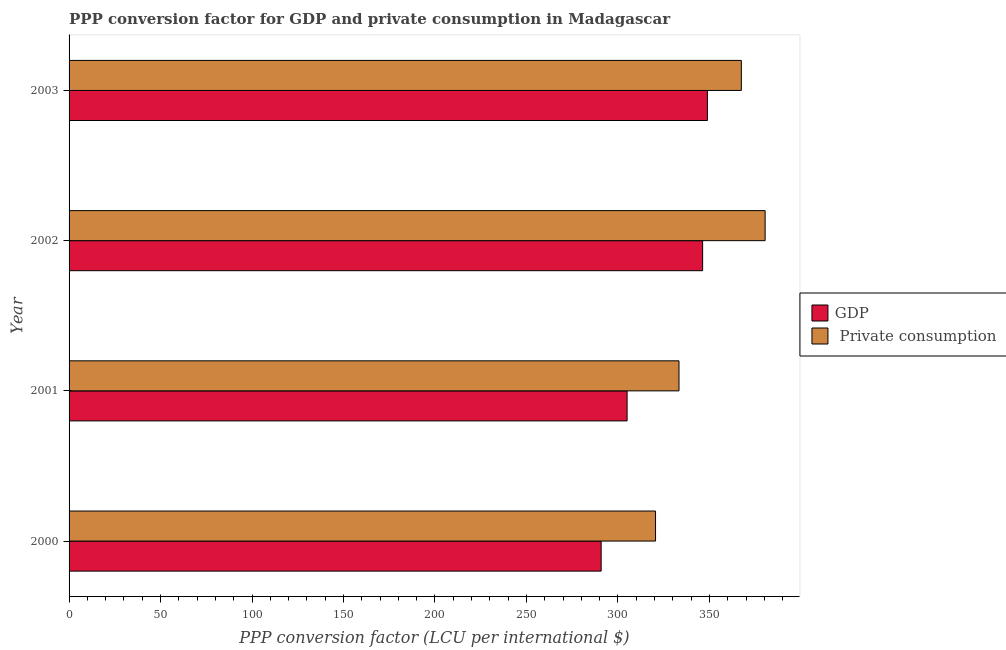How many different coloured bars are there?
Make the answer very short. 2. Are the number of bars per tick equal to the number of legend labels?
Give a very brief answer. Yes. How many bars are there on the 2nd tick from the top?
Ensure brevity in your answer.  2. In how many cases, is the number of bars for a given year not equal to the number of legend labels?
Provide a succinct answer. 0. What is the ppp conversion factor for gdp in 2001?
Make the answer very short. 305.01. Across all years, what is the maximum ppp conversion factor for gdp?
Offer a very short reply. 348.91. Across all years, what is the minimum ppp conversion factor for gdp?
Your response must be concise. 290.83. In which year was the ppp conversion factor for private consumption minimum?
Provide a succinct answer. 2000. What is the total ppp conversion factor for private consumption in the graph?
Provide a succinct answer. 1401.83. What is the difference between the ppp conversion factor for gdp in 2001 and that in 2003?
Your answer should be compact. -43.89. What is the difference between the ppp conversion factor for private consumption in 2000 and the ppp conversion factor for gdp in 2003?
Your answer should be very brief. -28.35. What is the average ppp conversion factor for gdp per year?
Ensure brevity in your answer.  322.76. In the year 2003, what is the difference between the ppp conversion factor for gdp and ppp conversion factor for private consumption?
Provide a short and direct response. -18.54. In how many years, is the ppp conversion factor for private consumption greater than 40 LCU?
Make the answer very short. 4. What is the ratio of the ppp conversion factor for private consumption in 2000 to that in 2001?
Provide a succinct answer. 0.96. Is the ppp conversion factor for private consumption in 2000 less than that in 2003?
Keep it short and to the point. Yes. Is the difference between the ppp conversion factor for gdp in 2002 and 2003 greater than the difference between the ppp conversion factor for private consumption in 2002 and 2003?
Ensure brevity in your answer.  No. What is the difference between the highest and the second highest ppp conversion factor for gdp?
Offer a terse response. 2.62. What is the difference between the highest and the lowest ppp conversion factor for gdp?
Give a very brief answer. 58.08. In how many years, is the ppp conversion factor for private consumption greater than the average ppp conversion factor for private consumption taken over all years?
Make the answer very short. 2. Is the sum of the ppp conversion factor for gdp in 2002 and 2003 greater than the maximum ppp conversion factor for private consumption across all years?
Your answer should be very brief. Yes. What does the 2nd bar from the top in 2002 represents?
Provide a succinct answer. GDP. What does the 1st bar from the bottom in 2003 represents?
Provide a succinct answer. GDP. How many years are there in the graph?
Offer a very short reply. 4. What is the difference between two consecutive major ticks on the X-axis?
Give a very brief answer. 50. Does the graph contain any zero values?
Your answer should be compact. No. Does the graph contain grids?
Your response must be concise. No. How are the legend labels stacked?
Offer a terse response. Vertical. What is the title of the graph?
Offer a terse response. PPP conversion factor for GDP and private consumption in Madagascar. Does "Merchandise exports" appear as one of the legend labels in the graph?
Offer a very short reply. No. What is the label or title of the X-axis?
Keep it short and to the point. PPP conversion factor (LCU per international $). What is the label or title of the Y-axis?
Your answer should be compact. Year. What is the PPP conversion factor (LCU per international $) of GDP in 2000?
Your answer should be compact. 290.83. What is the PPP conversion factor (LCU per international $) in  Private consumption in 2000?
Your response must be concise. 320.56. What is the PPP conversion factor (LCU per international $) in GDP in 2001?
Ensure brevity in your answer.  305.01. What is the PPP conversion factor (LCU per international $) of  Private consumption in 2001?
Ensure brevity in your answer.  333.37. What is the PPP conversion factor (LCU per international $) in GDP in 2002?
Provide a short and direct response. 346.29. What is the PPP conversion factor (LCU per international $) of  Private consumption in 2002?
Offer a very short reply. 380.45. What is the PPP conversion factor (LCU per international $) in GDP in 2003?
Offer a terse response. 348.91. What is the PPP conversion factor (LCU per international $) in  Private consumption in 2003?
Your answer should be very brief. 367.45. Across all years, what is the maximum PPP conversion factor (LCU per international $) of GDP?
Your response must be concise. 348.91. Across all years, what is the maximum PPP conversion factor (LCU per international $) of  Private consumption?
Keep it short and to the point. 380.45. Across all years, what is the minimum PPP conversion factor (LCU per international $) in GDP?
Offer a terse response. 290.83. Across all years, what is the minimum PPP conversion factor (LCU per international $) in  Private consumption?
Provide a succinct answer. 320.56. What is the total PPP conversion factor (LCU per international $) in GDP in the graph?
Provide a short and direct response. 1291.04. What is the total PPP conversion factor (LCU per international $) in  Private consumption in the graph?
Make the answer very short. 1401.83. What is the difference between the PPP conversion factor (LCU per international $) of GDP in 2000 and that in 2001?
Your answer should be very brief. -14.18. What is the difference between the PPP conversion factor (LCU per international $) of  Private consumption in 2000 and that in 2001?
Your answer should be very brief. -12.82. What is the difference between the PPP conversion factor (LCU per international $) of GDP in 2000 and that in 2002?
Ensure brevity in your answer.  -55.46. What is the difference between the PPP conversion factor (LCU per international $) in  Private consumption in 2000 and that in 2002?
Your answer should be very brief. -59.9. What is the difference between the PPP conversion factor (LCU per international $) of GDP in 2000 and that in 2003?
Keep it short and to the point. -58.08. What is the difference between the PPP conversion factor (LCU per international $) in  Private consumption in 2000 and that in 2003?
Your response must be concise. -46.89. What is the difference between the PPP conversion factor (LCU per international $) of GDP in 2001 and that in 2002?
Your answer should be compact. -41.28. What is the difference between the PPP conversion factor (LCU per international $) in  Private consumption in 2001 and that in 2002?
Offer a terse response. -47.08. What is the difference between the PPP conversion factor (LCU per international $) in GDP in 2001 and that in 2003?
Provide a succinct answer. -43.89. What is the difference between the PPP conversion factor (LCU per international $) of  Private consumption in 2001 and that in 2003?
Make the answer very short. -34.08. What is the difference between the PPP conversion factor (LCU per international $) of GDP in 2002 and that in 2003?
Offer a terse response. -2.62. What is the difference between the PPP conversion factor (LCU per international $) of  Private consumption in 2002 and that in 2003?
Make the answer very short. 13. What is the difference between the PPP conversion factor (LCU per international $) of GDP in 2000 and the PPP conversion factor (LCU per international $) of  Private consumption in 2001?
Offer a very short reply. -42.54. What is the difference between the PPP conversion factor (LCU per international $) in GDP in 2000 and the PPP conversion factor (LCU per international $) in  Private consumption in 2002?
Make the answer very short. -89.62. What is the difference between the PPP conversion factor (LCU per international $) of GDP in 2000 and the PPP conversion factor (LCU per international $) of  Private consumption in 2003?
Give a very brief answer. -76.62. What is the difference between the PPP conversion factor (LCU per international $) in GDP in 2001 and the PPP conversion factor (LCU per international $) in  Private consumption in 2002?
Your answer should be very brief. -75.44. What is the difference between the PPP conversion factor (LCU per international $) of GDP in 2001 and the PPP conversion factor (LCU per international $) of  Private consumption in 2003?
Your answer should be compact. -62.44. What is the difference between the PPP conversion factor (LCU per international $) of GDP in 2002 and the PPP conversion factor (LCU per international $) of  Private consumption in 2003?
Provide a succinct answer. -21.16. What is the average PPP conversion factor (LCU per international $) in GDP per year?
Keep it short and to the point. 322.76. What is the average PPP conversion factor (LCU per international $) of  Private consumption per year?
Offer a very short reply. 350.46. In the year 2000, what is the difference between the PPP conversion factor (LCU per international $) of GDP and PPP conversion factor (LCU per international $) of  Private consumption?
Your answer should be very brief. -29.73. In the year 2001, what is the difference between the PPP conversion factor (LCU per international $) in GDP and PPP conversion factor (LCU per international $) in  Private consumption?
Provide a short and direct response. -28.36. In the year 2002, what is the difference between the PPP conversion factor (LCU per international $) of GDP and PPP conversion factor (LCU per international $) of  Private consumption?
Make the answer very short. -34.16. In the year 2003, what is the difference between the PPP conversion factor (LCU per international $) of GDP and PPP conversion factor (LCU per international $) of  Private consumption?
Your response must be concise. -18.54. What is the ratio of the PPP conversion factor (LCU per international $) of GDP in 2000 to that in 2001?
Ensure brevity in your answer.  0.95. What is the ratio of the PPP conversion factor (LCU per international $) of  Private consumption in 2000 to that in 2001?
Give a very brief answer. 0.96. What is the ratio of the PPP conversion factor (LCU per international $) of GDP in 2000 to that in 2002?
Give a very brief answer. 0.84. What is the ratio of the PPP conversion factor (LCU per international $) of  Private consumption in 2000 to that in 2002?
Your answer should be very brief. 0.84. What is the ratio of the PPP conversion factor (LCU per international $) of GDP in 2000 to that in 2003?
Give a very brief answer. 0.83. What is the ratio of the PPP conversion factor (LCU per international $) in  Private consumption in 2000 to that in 2003?
Your answer should be compact. 0.87. What is the ratio of the PPP conversion factor (LCU per international $) of GDP in 2001 to that in 2002?
Give a very brief answer. 0.88. What is the ratio of the PPP conversion factor (LCU per international $) in  Private consumption in 2001 to that in 2002?
Provide a short and direct response. 0.88. What is the ratio of the PPP conversion factor (LCU per international $) in GDP in 2001 to that in 2003?
Offer a terse response. 0.87. What is the ratio of the PPP conversion factor (LCU per international $) in  Private consumption in 2001 to that in 2003?
Make the answer very short. 0.91. What is the ratio of the PPP conversion factor (LCU per international $) in GDP in 2002 to that in 2003?
Your answer should be compact. 0.99. What is the ratio of the PPP conversion factor (LCU per international $) in  Private consumption in 2002 to that in 2003?
Provide a succinct answer. 1.04. What is the difference between the highest and the second highest PPP conversion factor (LCU per international $) of GDP?
Your response must be concise. 2.62. What is the difference between the highest and the second highest PPP conversion factor (LCU per international $) in  Private consumption?
Provide a succinct answer. 13. What is the difference between the highest and the lowest PPP conversion factor (LCU per international $) of GDP?
Provide a short and direct response. 58.08. What is the difference between the highest and the lowest PPP conversion factor (LCU per international $) of  Private consumption?
Provide a short and direct response. 59.9. 